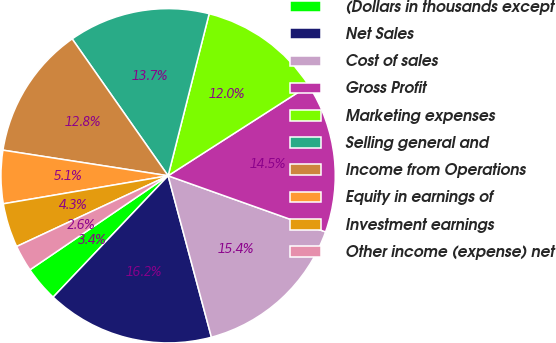Convert chart. <chart><loc_0><loc_0><loc_500><loc_500><pie_chart><fcel>(Dollars in thousands except<fcel>Net Sales<fcel>Cost of sales<fcel>Gross Profit<fcel>Marketing expenses<fcel>Selling general and<fcel>Income from Operations<fcel>Equity in earnings of<fcel>Investment earnings<fcel>Other income (expense) net<nl><fcel>3.42%<fcel>16.24%<fcel>15.38%<fcel>14.53%<fcel>11.97%<fcel>13.68%<fcel>12.82%<fcel>5.13%<fcel>4.27%<fcel>2.56%<nl></chart> 